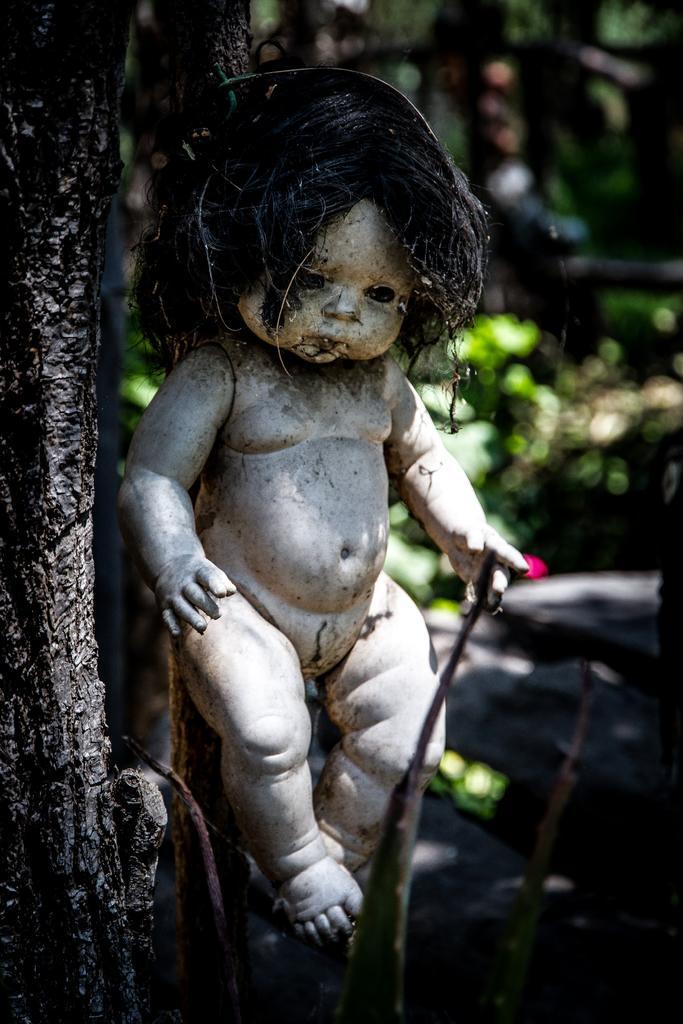Can you describe this image briefly? In this picture we can see a baby doll in the front, on the left side there is a tree, in the background we can see some plants, there is a blurry background. 